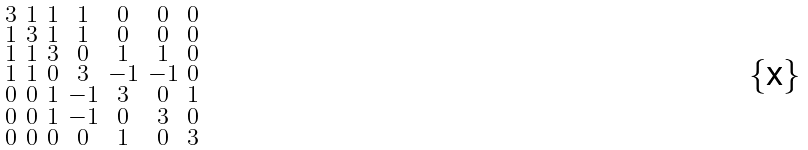Convert formula to latex. <formula><loc_0><loc_0><loc_500><loc_500>\begin{smallmatrix} 3 & 1 & 1 & 1 & 0 & 0 & 0 \\ 1 & 3 & 1 & 1 & 0 & 0 & 0 \\ 1 & 1 & 3 & 0 & 1 & 1 & 0 \\ 1 & 1 & 0 & 3 & - 1 & - 1 & 0 \\ 0 & 0 & 1 & - 1 & 3 & 0 & 1 \\ 0 & 0 & 1 & - 1 & 0 & 3 & 0 \\ 0 & 0 & 0 & 0 & 1 & 0 & 3 \end{smallmatrix}</formula> 